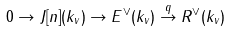Convert formula to latex. <formula><loc_0><loc_0><loc_500><loc_500>0 \to J [ n ] ( k _ { v } ) \to E ^ { \vee } ( k _ { v } ) \stackrel { q } \to R ^ { \vee } ( k _ { v } )</formula> 